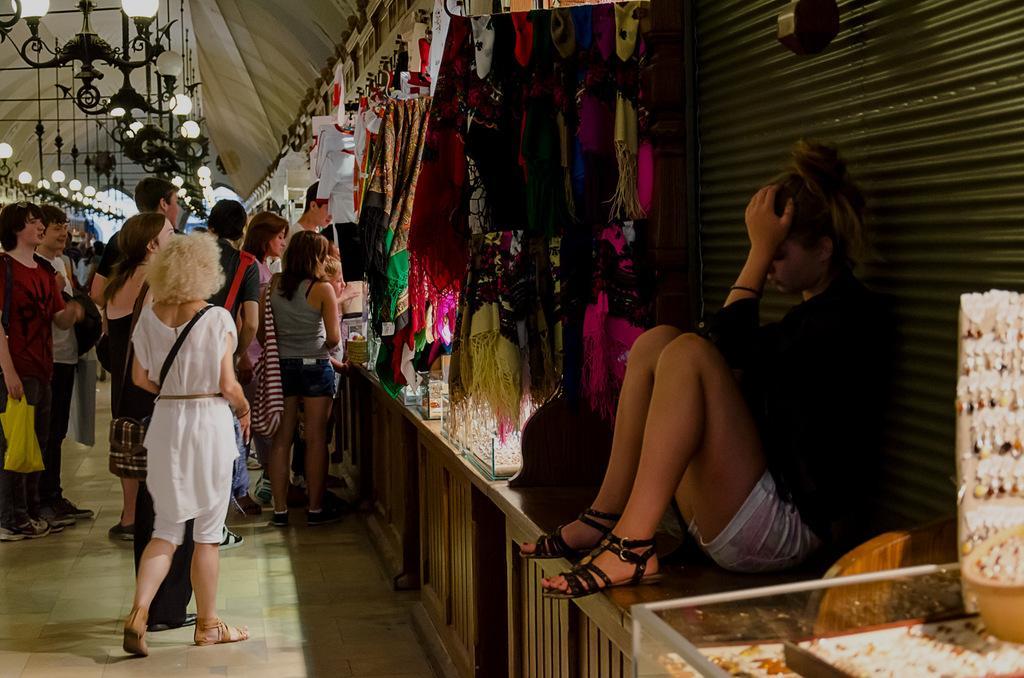In one or two sentences, can you explain what this image depicts? In this image there are few people visible in front of shop, in the shop there are few clothes hanging through hanger on the right side there is a woman sitting in front of shatter on the bench there are some trees, on which there are some hangings visible, in the top left corner there are some lights visible. 